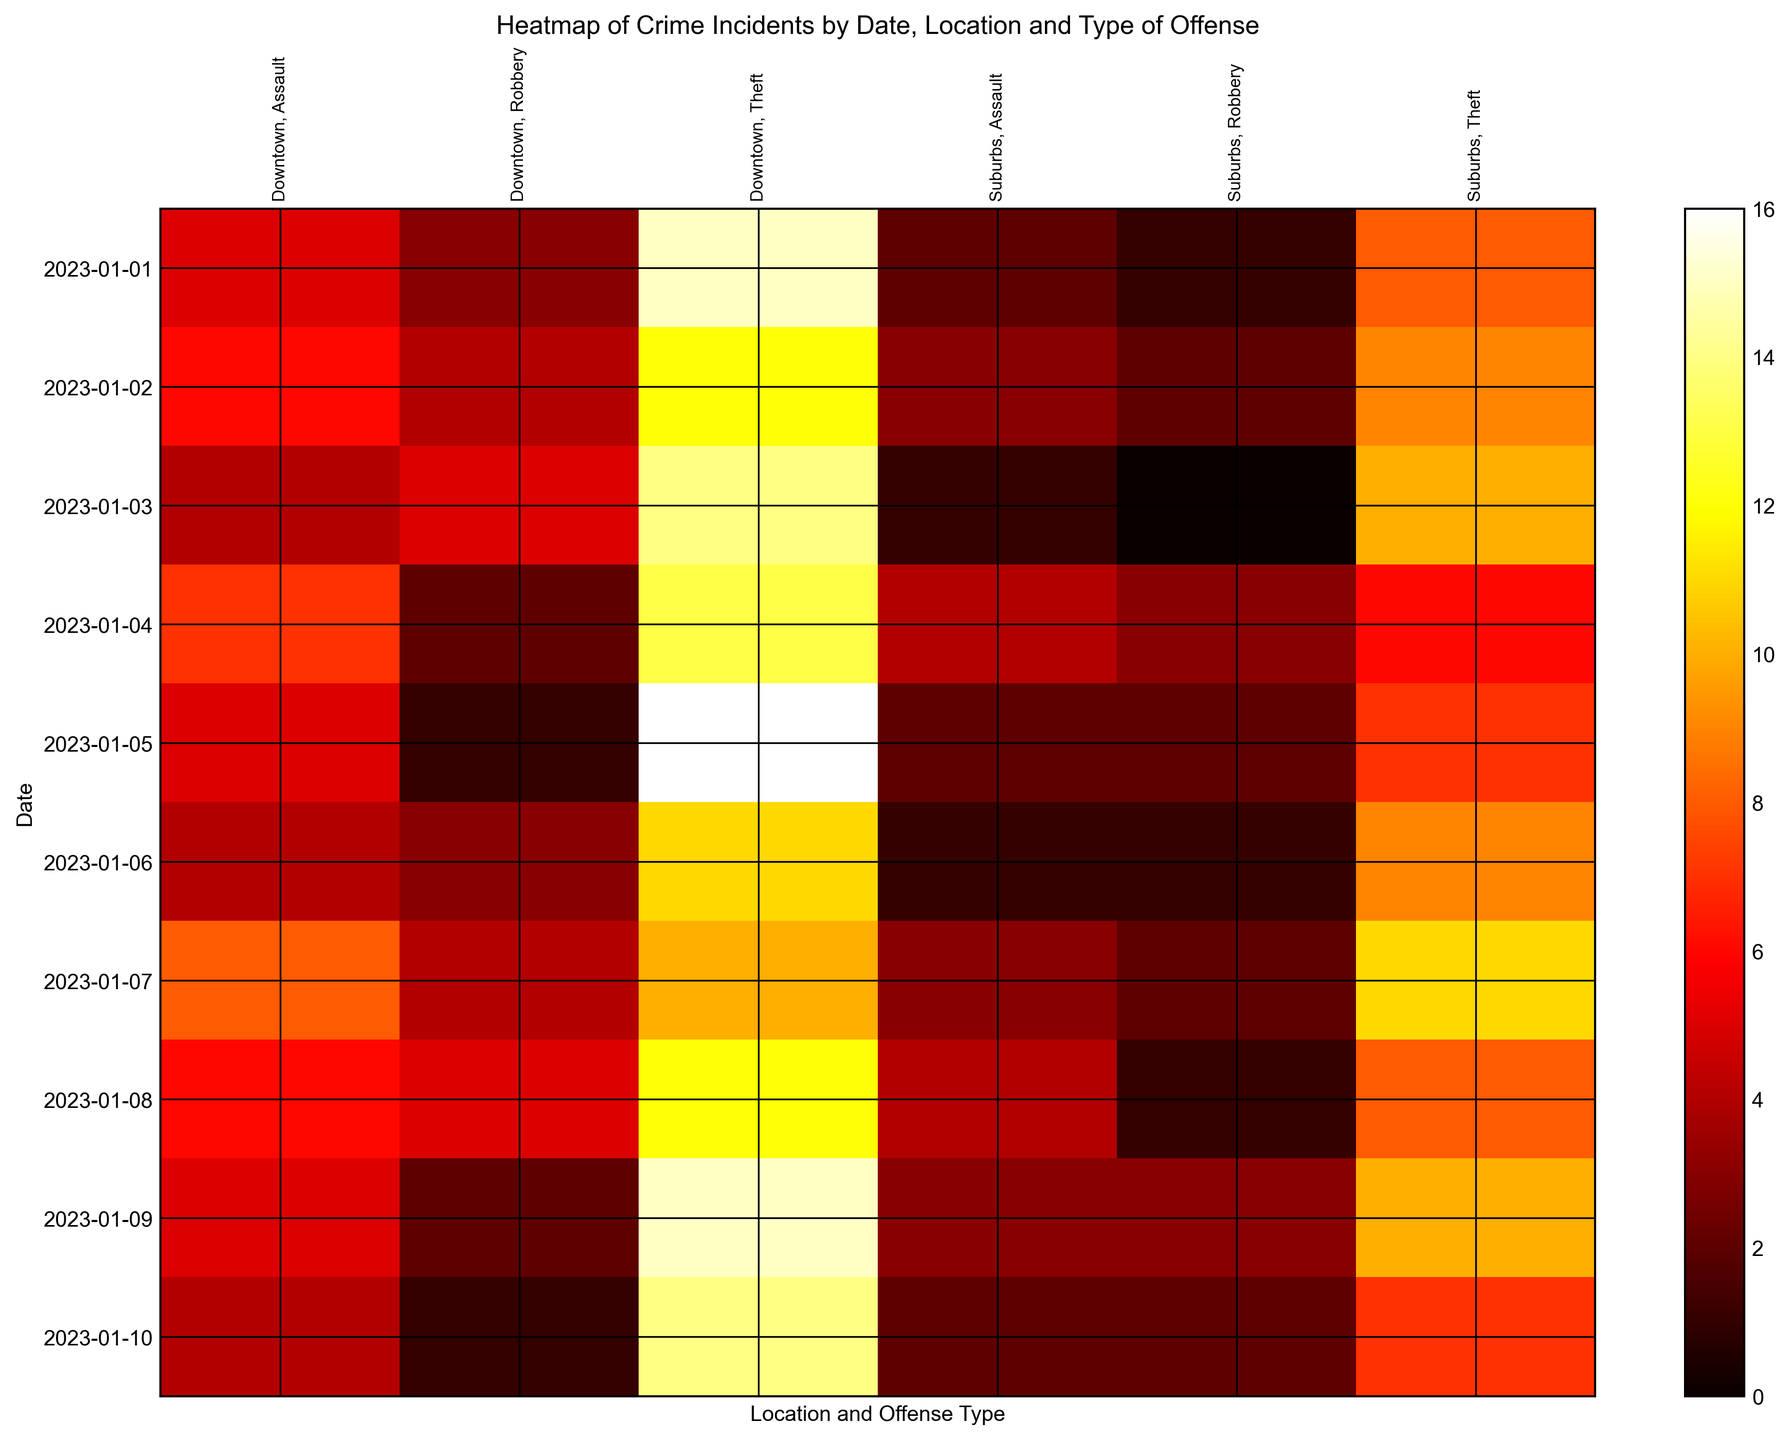Which offense type had the highest incident count in Downtown on January 5th? Locate the column corresponding to Downtown and January 5th, then compare the incident counts for all offense types. Theft has the highest count.
Answer: Theft How did the frequency of robbery in Suburbs change from January 1st to January 10th? Observe the column corresponding to 'Suburbs, Robbery' and track the changes in incident counts from January 1st to January 10th: 1, 2, 0, 3, 2, 1, 2, 1, 3, 2. The counts tend to fluctuate without a clear increasing or decreasing trend.
Answer: Fluctuated Is the overall frequency of assault higher in Downtown or Suburbs across all dates? Sum the incident counts for Assault in both Downtown and Suburbs. Downtown: 5+6+4+7+5+4+8+6+5+4 = 54; Suburbs: 2+3+1+4+2+1+3+4+3+2 = 25. Downtown has higher total frequency.
Answer: Downtown What is the average number of theft incidents in Downtown from January 1st to January 10th? Sum the theft incidents in Downtown: 15+12+14+13+16+11+10+12+15+14 = 132. Divide by number of days: 132/10 = 13.2.
Answer: 13.2 Which combination of location and offense type had the least incidents on January 1st? Locate January 1st row and compare all incident counts: 5, 15, 3, 2, 8, 1. The least count is 1 (Suburbs, Robbery).
Answer: Suburbs, Robbery Which offense type in Downtown showed the greatest variation in incident counts over the observed dates? Check the incident counts for each offense type in Downtown over the dates: Assault (5, 6, 4, 7, 5, 4, 8, 6, 5, 4), Theft (15, 12, 14, 13, 16, 11, 10, 12, 15, 14), Robbery (3, 4, 5, 2, 1, 3, 4, 5, 2, 1). Calculate the range (max - min): Assault = 8-4=4, Theft = 16-10=6, Robbery = 5-1=4. Theft has the greatest variation.
Answer: Theft What is the combined incidence count for Assault and Theft in Suburbs on January 7th? Find the incident counts for Assault and Theft in Suburbs on January 7th: Assault = 3, Theft = 11. Add them together: 3 + 11 = 14.
Answer: 14 Between January 1st and January 10th, which day had the highest total crime incidents in Downtown? Calculate the total daily crime incidents for Downtown by summing the counts for each offense on each day, then identify the highest total: Jan 5th (5+16+1=22)
Answer: January 5th 